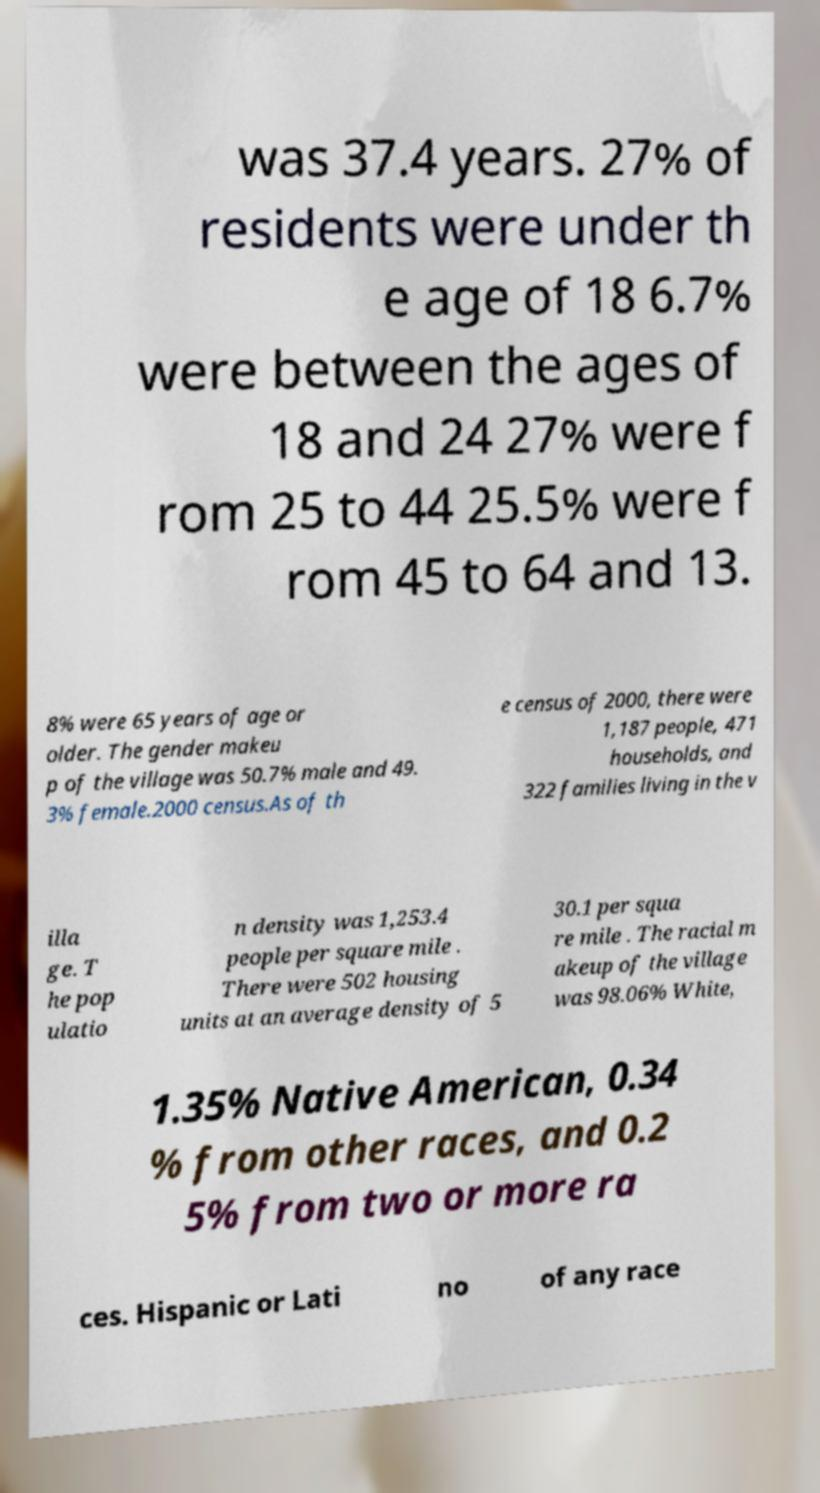What messages or text are displayed in this image? I need them in a readable, typed format. was 37.4 years. 27% of residents were under th e age of 18 6.7% were between the ages of 18 and 24 27% were f rom 25 to 44 25.5% were f rom 45 to 64 and 13. 8% were 65 years of age or older. The gender makeu p of the village was 50.7% male and 49. 3% female.2000 census.As of th e census of 2000, there were 1,187 people, 471 households, and 322 families living in the v illa ge. T he pop ulatio n density was 1,253.4 people per square mile . There were 502 housing units at an average density of 5 30.1 per squa re mile . The racial m akeup of the village was 98.06% White, 1.35% Native American, 0.34 % from other races, and 0.2 5% from two or more ra ces. Hispanic or Lati no of any race 